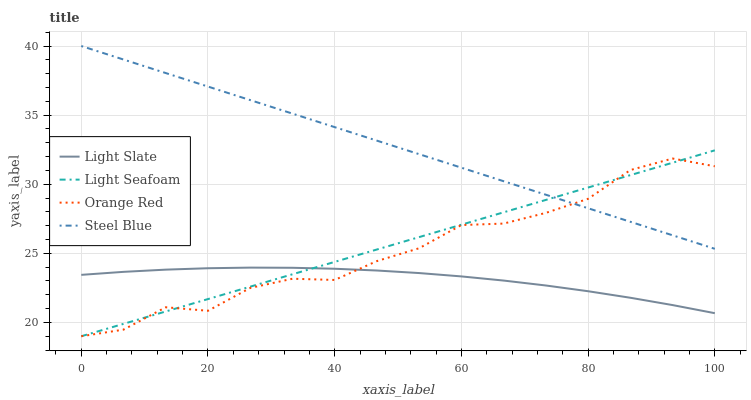Does Light Slate have the minimum area under the curve?
Answer yes or no. Yes. Does Steel Blue have the maximum area under the curve?
Answer yes or no. Yes. Does Light Seafoam have the minimum area under the curve?
Answer yes or no. No. Does Light Seafoam have the maximum area under the curve?
Answer yes or no. No. Is Light Seafoam the smoothest?
Answer yes or no. Yes. Is Orange Red the roughest?
Answer yes or no. Yes. Is Orange Red the smoothest?
Answer yes or no. No. Is Light Seafoam the roughest?
Answer yes or no. No. Does Light Seafoam have the lowest value?
Answer yes or no. Yes. Does Steel Blue have the lowest value?
Answer yes or no. No. Does Steel Blue have the highest value?
Answer yes or no. Yes. Does Light Seafoam have the highest value?
Answer yes or no. No. Is Light Slate less than Steel Blue?
Answer yes or no. Yes. Is Steel Blue greater than Light Slate?
Answer yes or no. Yes. Does Steel Blue intersect Light Seafoam?
Answer yes or no. Yes. Is Steel Blue less than Light Seafoam?
Answer yes or no. No. Is Steel Blue greater than Light Seafoam?
Answer yes or no. No. Does Light Slate intersect Steel Blue?
Answer yes or no. No. 